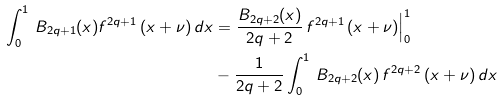<formula> <loc_0><loc_0><loc_500><loc_500>\int _ { 0 } ^ { 1 } \, B _ { 2 q + 1 } ( x ) f ^ { 2 q + 1 } \, ( x + \nu ) \, d x & = \frac { B _ { 2 q + 2 } ( x ) } { 2 q + 2 } \, f ^ { 2 q + 1 } \, ( x + \nu ) \Big | _ { 0 } ^ { 1 } \\ & - \frac { 1 } { 2 q + 2 } \int _ { 0 } ^ { 1 } \, B _ { 2 q + 2 } ( x ) \, f ^ { 2 q + 2 } \, ( x + \nu ) \, d x \\</formula> 